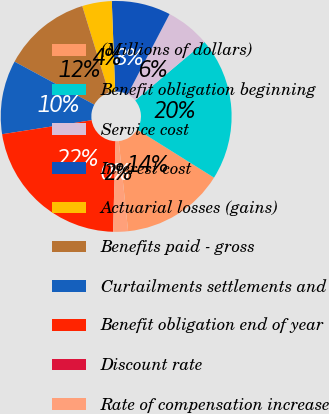<chart> <loc_0><loc_0><loc_500><loc_500><pie_chart><fcel>(Millions of dollars)<fcel>Benefit obligation beginning<fcel>Service cost<fcel>Interest cost<fcel>Actuarial losses (gains)<fcel>Benefits paid - gross<fcel>Curtailments settlements and<fcel>Benefit obligation end of year<fcel>Discount rate<fcel>Rate of compensation increase<nl><fcel>14.45%<fcel>20.04%<fcel>6.2%<fcel>8.26%<fcel>4.14%<fcel>12.39%<fcel>10.33%<fcel>22.1%<fcel>0.01%<fcel>2.07%<nl></chart> 